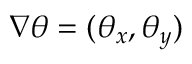<formula> <loc_0><loc_0><loc_500><loc_500>\nabla \theta = ( \theta _ { x } , \theta _ { y } )</formula> 